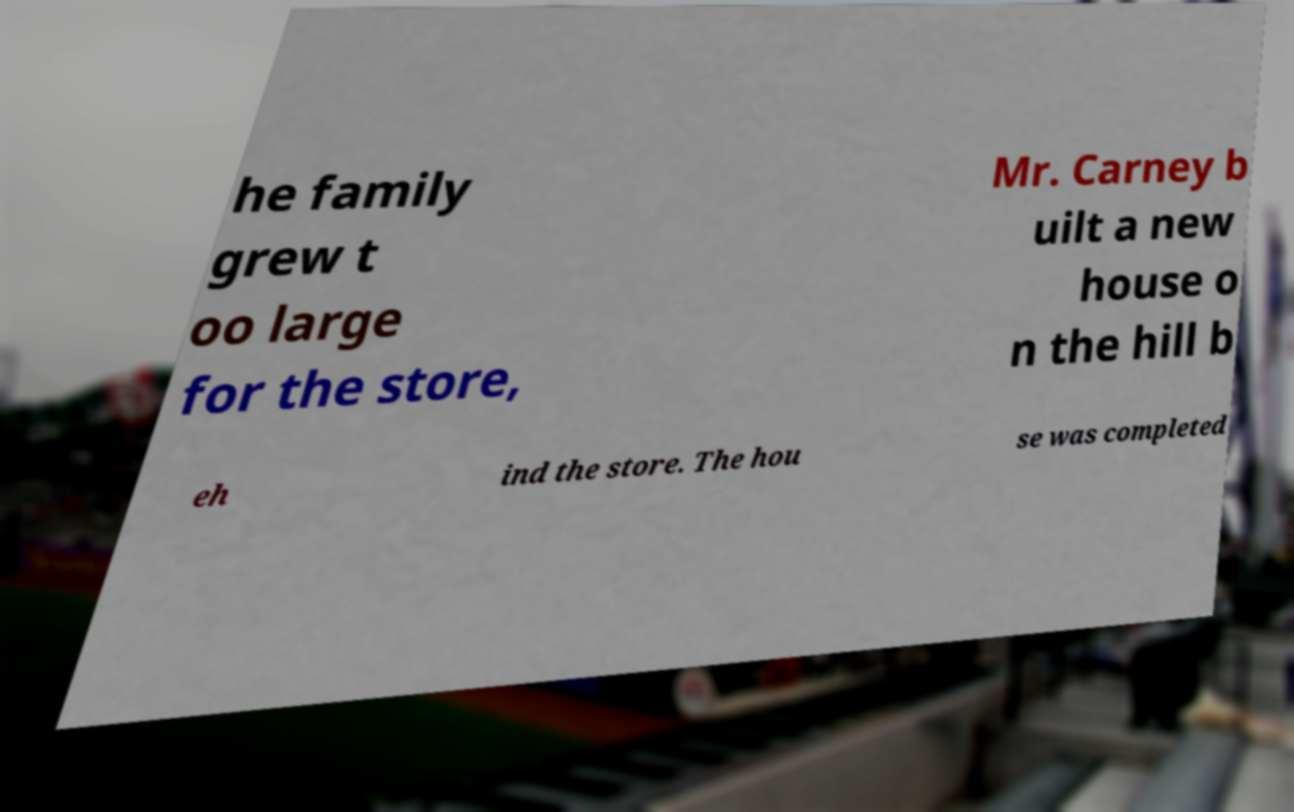Please read and relay the text visible in this image. What does it say? he family grew t oo large for the store, Mr. Carney b uilt a new house o n the hill b eh ind the store. The hou se was completed 